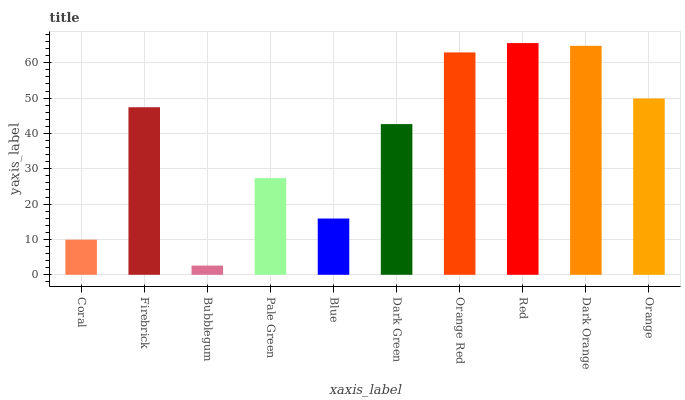Is Bubblegum the minimum?
Answer yes or no. Yes. Is Red the maximum?
Answer yes or no. Yes. Is Firebrick the minimum?
Answer yes or no. No. Is Firebrick the maximum?
Answer yes or no. No. Is Firebrick greater than Coral?
Answer yes or no. Yes. Is Coral less than Firebrick?
Answer yes or no. Yes. Is Coral greater than Firebrick?
Answer yes or no. No. Is Firebrick less than Coral?
Answer yes or no. No. Is Firebrick the high median?
Answer yes or no. Yes. Is Dark Green the low median?
Answer yes or no. Yes. Is Dark Orange the high median?
Answer yes or no. No. Is Orange the low median?
Answer yes or no. No. 